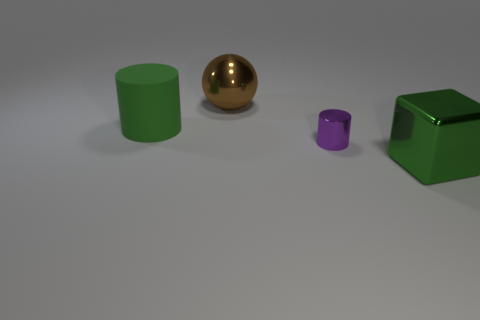Add 1 red rubber cubes. How many objects exist? 5 Subtract all balls. How many objects are left? 3 Add 3 purple metal things. How many purple metal things exist? 4 Subtract 0 green spheres. How many objects are left? 4 Subtract all small blue matte cylinders. Subtract all large things. How many objects are left? 1 Add 1 tiny purple shiny cylinders. How many tiny purple shiny cylinders are left? 2 